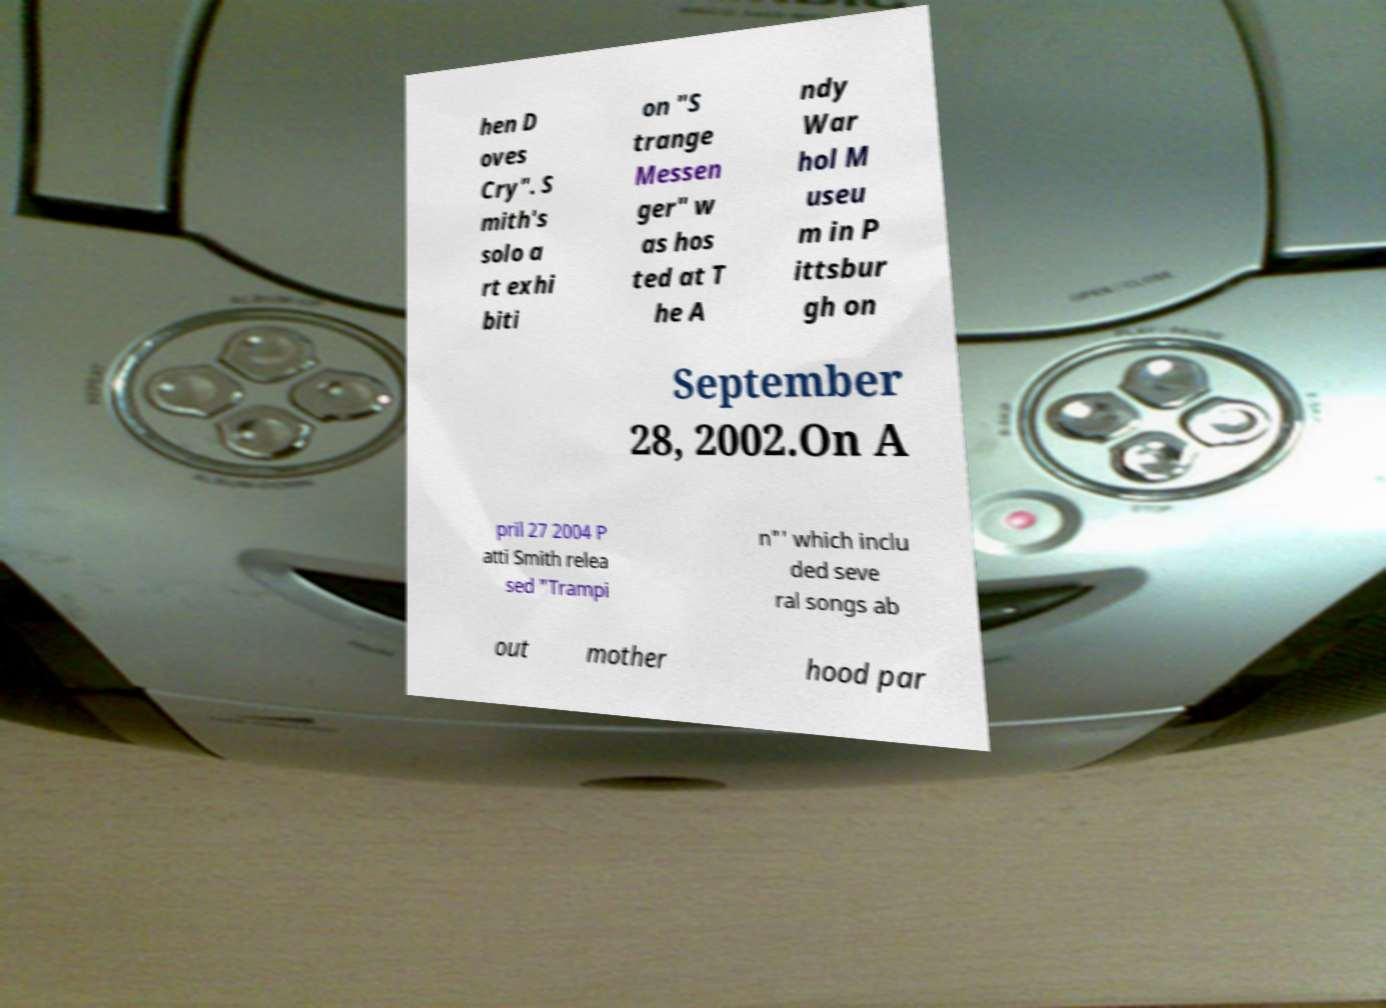Please read and relay the text visible in this image. What does it say? hen D oves Cry". S mith's solo a rt exhi biti on "S trange Messen ger" w as hos ted at T he A ndy War hol M useu m in P ittsbur gh on September 28, 2002.On A pril 27 2004 P atti Smith relea sed "Trampi n"' which inclu ded seve ral songs ab out mother hood par 